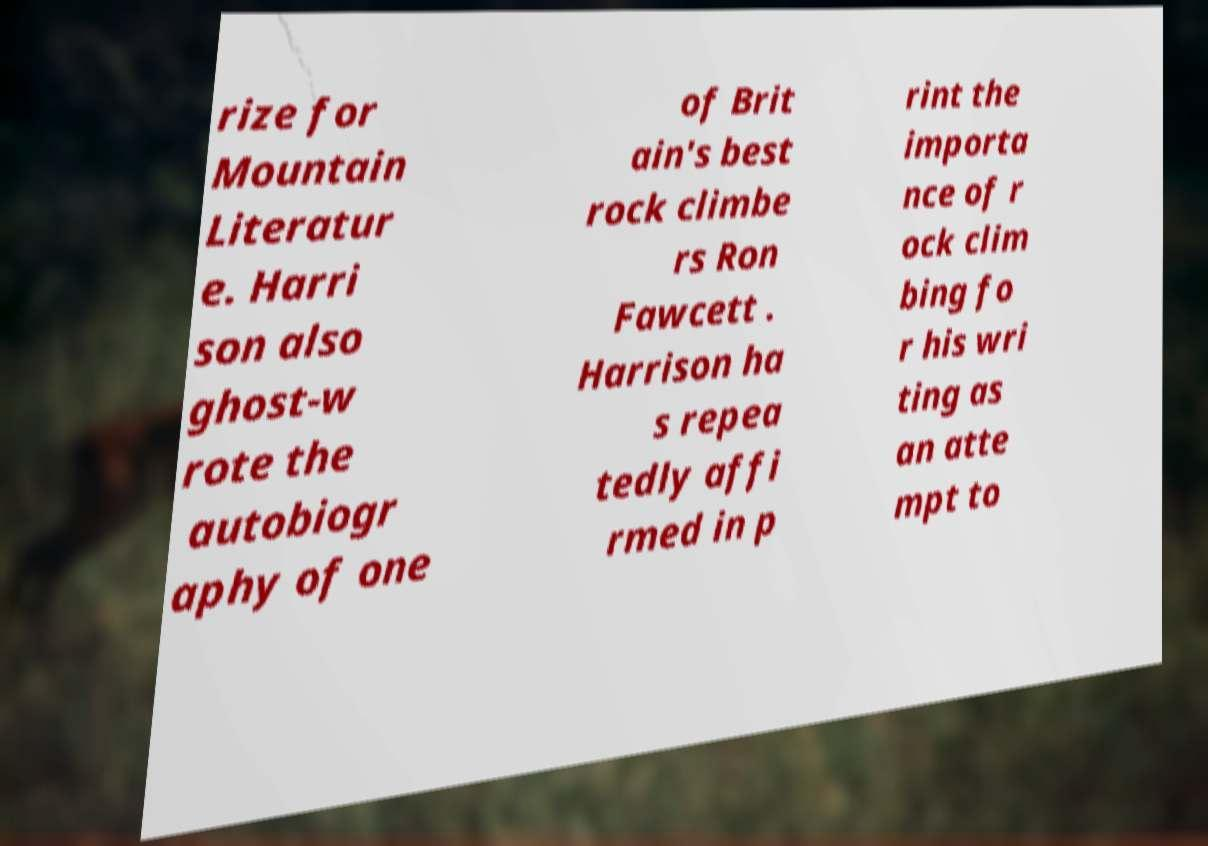Could you assist in decoding the text presented in this image and type it out clearly? rize for Mountain Literatur e. Harri son also ghost-w rote the autobiogr aphy of one of Brit ain's best rock climbe rs Ron Fawcett . Harrison ha s repea tedly affi rmed in p rint the importa nce of r ock clim bing fo r his wri ting as an atte mpt to 